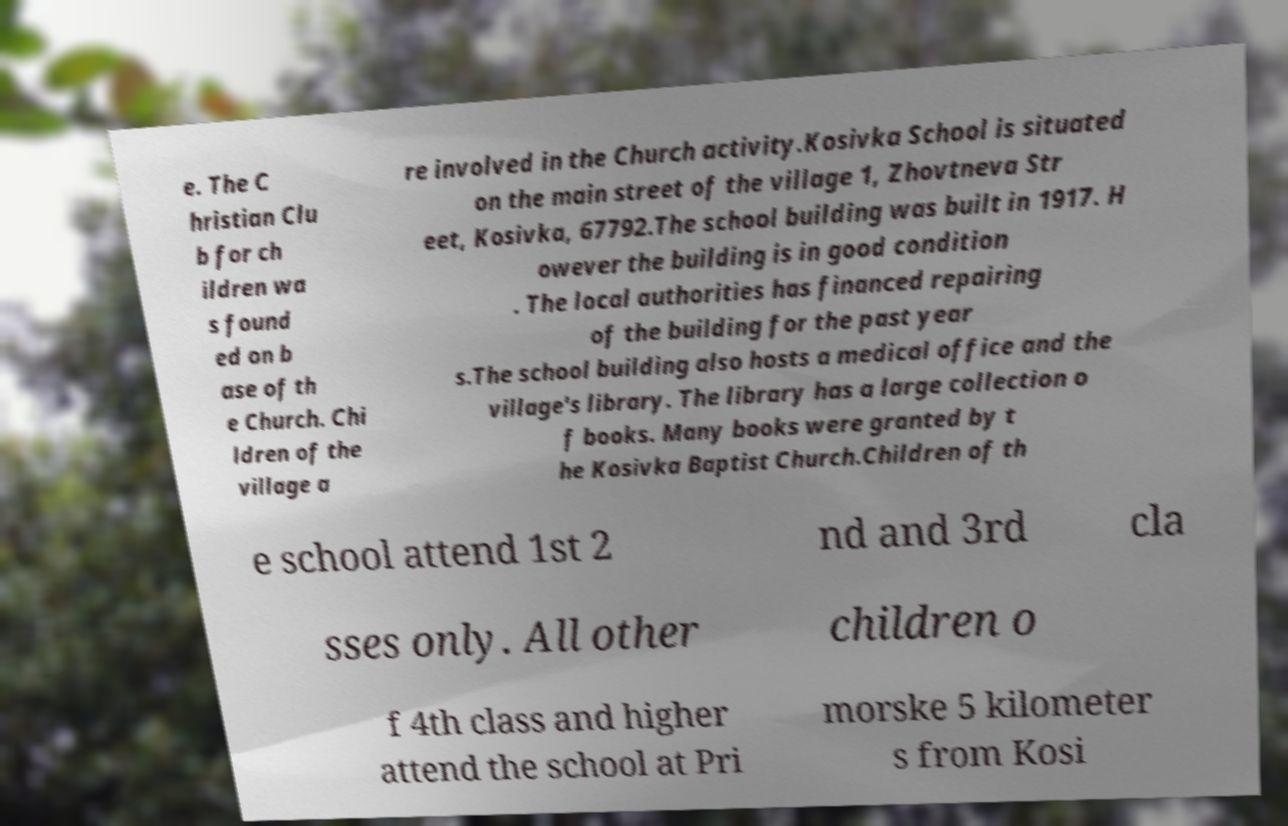Please read and relay the text visible in this image. What does it say? e. The C hristian Clu b for ch ildren wa s found ed on b ase of th e Church. Chi ldren of the village a re involved in the Church activity.Kosivka School is situated on the main street of the village 1, Zhovtneva Str eet, Kosivka, 67792.The school building was built in 1917. H owever the building is in good condition . The local authorities has financed repairing of the building for the past year s.The school building also hosts a medical office and the village's library. The library has a large collection o f books. Many books were granted by t he Kosivka Baptist Church.Children of th e school attend 1st 2 nd and 3rd cla sses only. All other children o f 4th class and higher attend the school at Pri morske 5 kilometer s from Kosi 